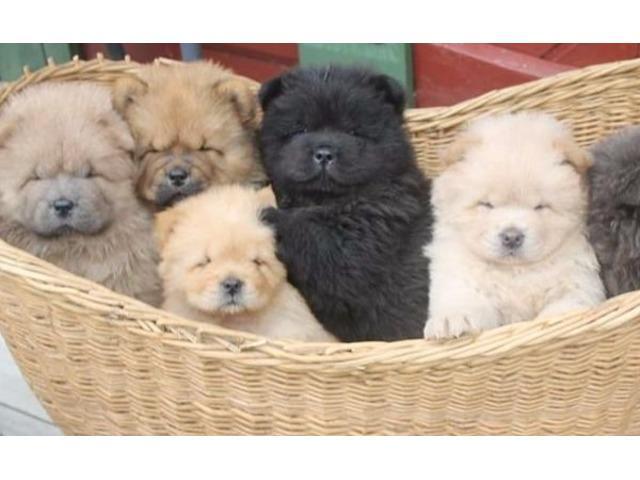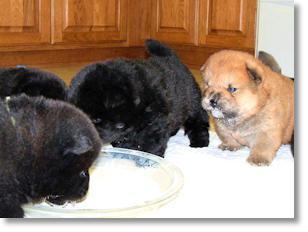The first image is the image on the left, the second image is the image on the right. For the images displayed, is the sentence "All images show multiple chow puppies, and the left image contains at least five camera-facing puppies." factually correct? Answer yes or no. Yes. 